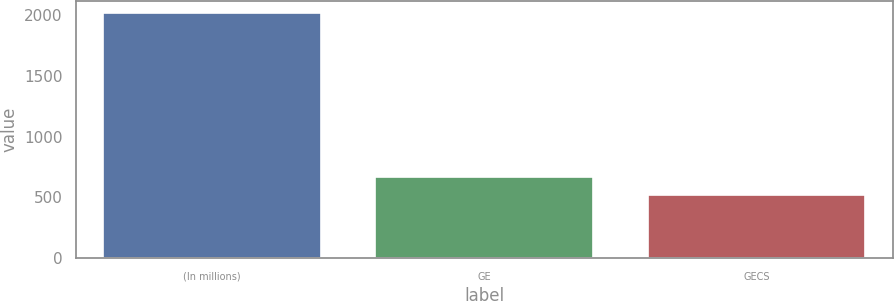Convert chart. <chart><loc_0><loc_0><loc_500><loc_500><bar_chart><fcel>(In millions)<fcel>GE<fcel>GECS<nl><fcel>2011<fcel>666.4<fcel>517<nl></chart> 